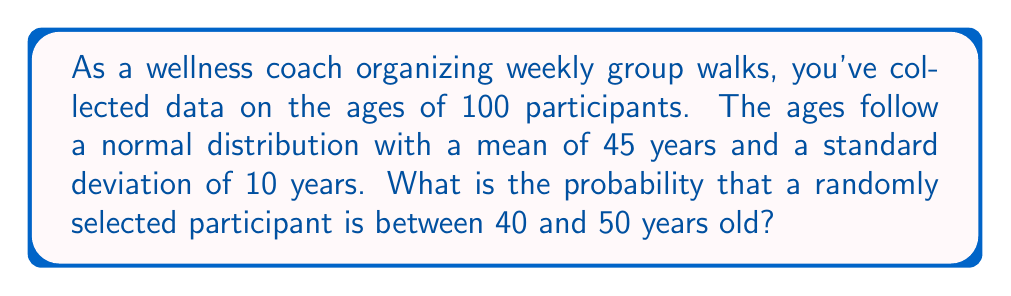Give your solution to this math problem. To solve this problem, we'll use the properties of the normal distribution and the concept of z-scores.

Step 1: Identify the given information
- The ages follow a normal distribution
- Mean (μ) = 45 years
- Standard deviation (σ) = 10 years
- We want to find P(40 < X < 50), where X is the age of a randomly selected participant

Step 2: Calculate the z-scores for the lower and upper bounds
z-score formula: $z = \frac{x - \mu}{\sigma}$

For x = 40: $z_1 = \frac{40 - 45}{10} = -0.5$
For x = 50: $z_2 = \frac{50 - 45}{10} = 0.5$

Step 3: Use the standard normal distribution table or a calculator to find the area between these z-scores

The probability is equal to the area between z = -0.5 and z = 0.5 under the standard normal curve.

Using a standard normal table or calculator:
P(-0.5 < Z < 0.5) = P(Z < 0.5) - P(Z < -0.5)
                  = 0.6915 - 0.3085
                  = 0.3830

Step 4: Convert the result to a percentage
0.3830 * 100 = 38.30%

Therefore, the probability that a randomly selected participant is between 40 and 50 years old is approximately 38.30%.
Answer: 38.30% 